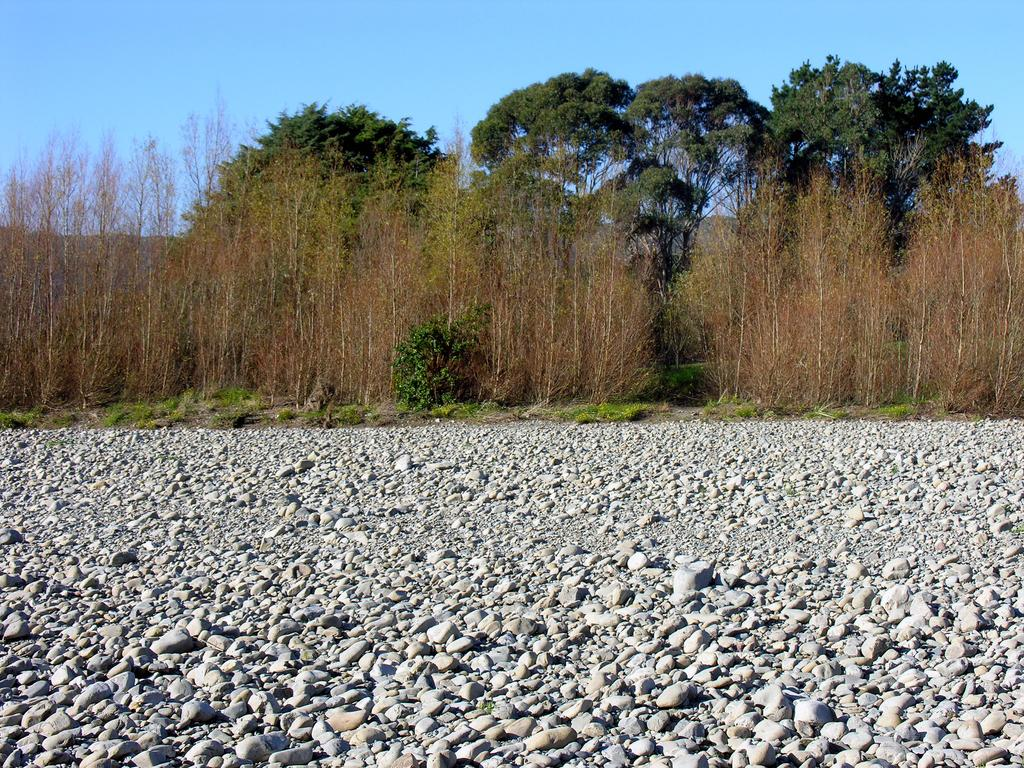What type of natural elements can be seen in the image? There are stones, grass, plants, and trees in the image. What is the color of the grass in the image? The grass in the image is green. What is visible in the background of the image? The sky is visible in the background of the image. What type of corn can be seen growing among the stones in the image? There is no corn present in the image; it features stones, grass, plants, and trees. What type of treatment is being administered to the plants in the image? There is no indication of any treatment being administered to the plants in the image. 